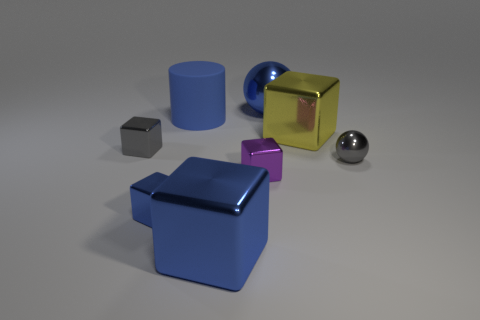Subtract 1 cubes. How many cubes are left? 4 Subtract all red blocks. Subtract all green balls. How many blocks are left? 5 Add 2 small purple cylinders. How many objects exist? 10 Subtract all cylinders. How many objects are left? 7 Add 6 big blue metal balls. How many big blue metal balls are left? 7 Add 1 large blue rubber cylinders. How many large blue rubber cylinders exist? 2 Subtract 0 green cylinders. How many objects are left? 8 Subtract all big cyan matte cylinders. Subtract all yellow metallic blocks. How many objects are left? 7 